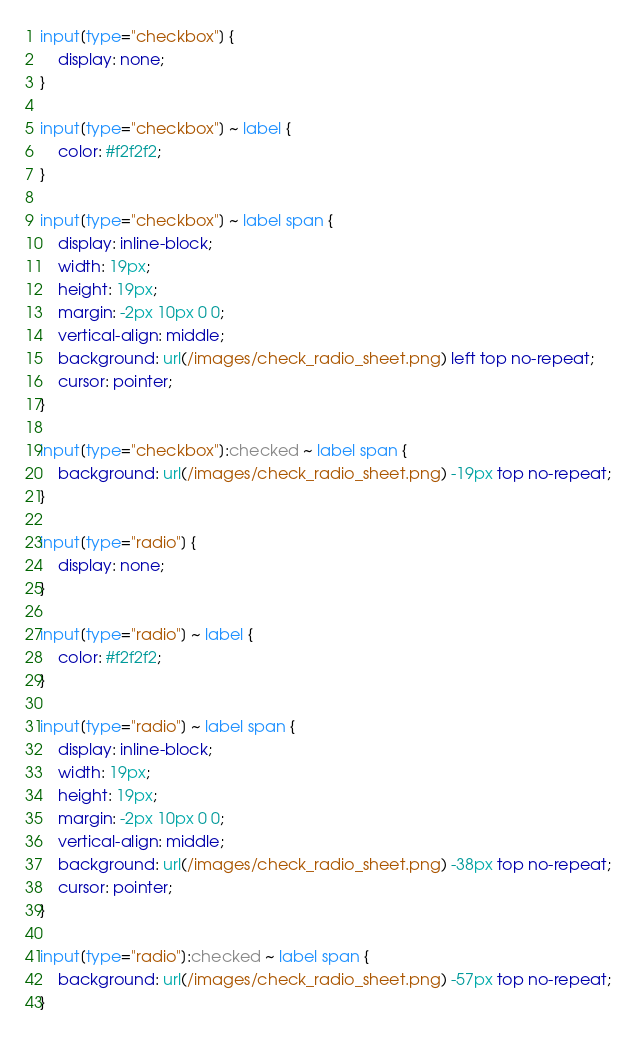<code> <loc_0><loc_0><loc_500><loc_500><_CSS_>input[type="checkbox"] {
    display: none;
}

input[type="checkbox"] ~ label {
    color: #f2f2f2;
}

input[type="checkbox"] ~ label span {
    display: inline-block;
    width: 19px;
    height: 19px;
    margin: -2px 10px 0 0;
    vertical-align: middle;
    background: url(/images/check_radio_sheet.png) left top no-repeat;
    cursor: pointer;
}

input[type="checkbox"]:checked ~ label span {
    background: url(/images/check_radio_sheet.png) -19px top no-repeat;
}

input[type="radio"] {
    display: none;
}

input[type="radio"] ~ label {
    color: #f2f2f2;
}

input[type="radio"] ~ label span {
    display: inline-block;
    width: 19px;
    height: 19px;
    margin: -2px 10px 0 0;
    vertical-align: middle;
    background: url(/images/check_radio_sheet.png) -38px top no-repeat;
    cursor: pointer;
}

input[type="radio"]:checked ~ label span {
    background: url(/images/check_radio_sheet.png) -57px top no-repeat;
}</code> 